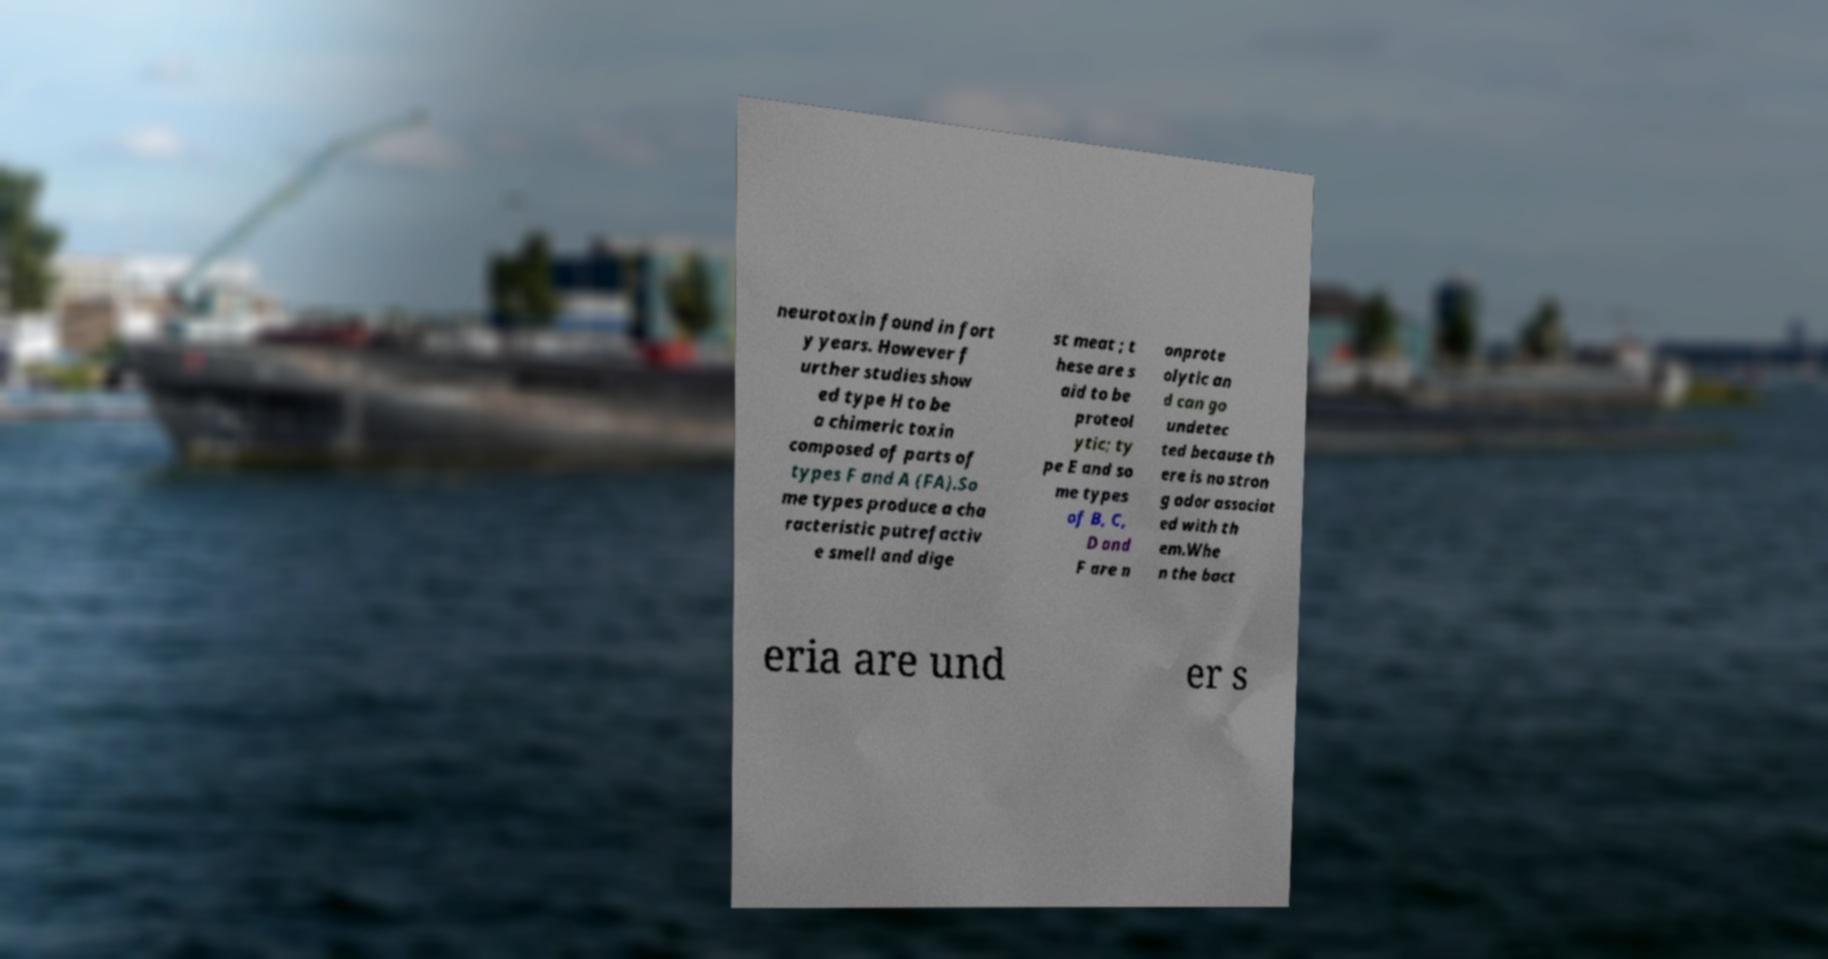What messages or text are displayed in this image? I need them in a readable, typed format. neurotoxin found in fort y years. However f urther studies show ed type H to be a chimeric toxin composed of parts of types F and A (FA).So me types produce a cha racteristic putrefactiv e smell and dige st meat ; t hese are s aid to be proteol ytic; ty pe E and so me types of B, C, D and F are n onprote olytic an d can go undetec ted because th ere is no stron g odor associat ed with th em.Whe n the bact eria are und er s 